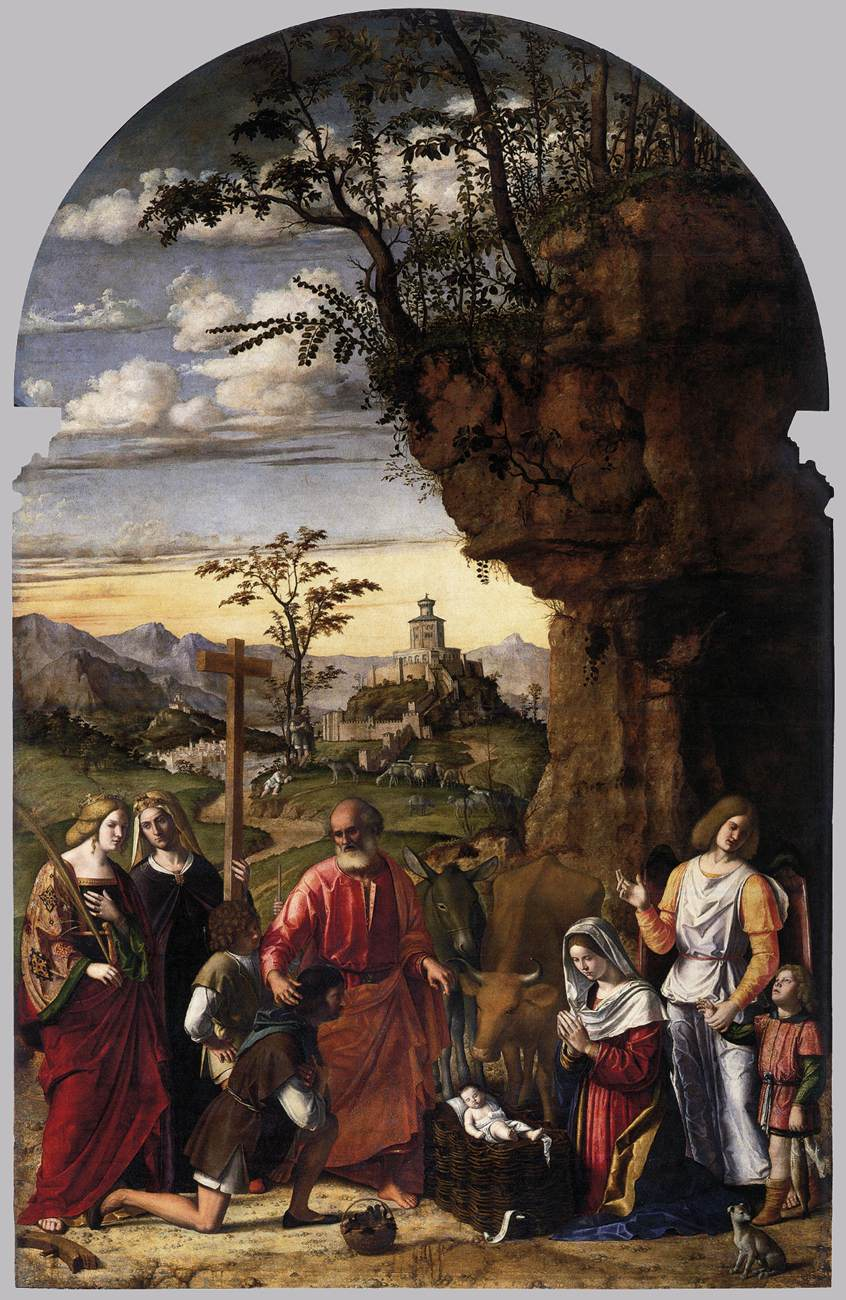What fantastical elements could you add to reinterpret this painting in a magical realism style? In a magical realism reinterpretation, fantastical elements would blend seamlessly with the realistic depiction of the scene. The towering cliff could serve as a lookout for ethereal guardian spirits, their semi-transparent forms gliding gracefully through the air. The distant town might shimmer with otherworldly light, its buildings displaying intricate, enchanted architectural designs. Instead of ordinary animals, mythical creatures like unicorns or phoenixes might gather around the Christ Child, their presence adding a layer of mystique. The figures could be adorned with delicate, glowing halos, signifying their divine connection. Wisps of magical energy could float around, their iridescent trails adding a surreal charm to the already divine setting. 